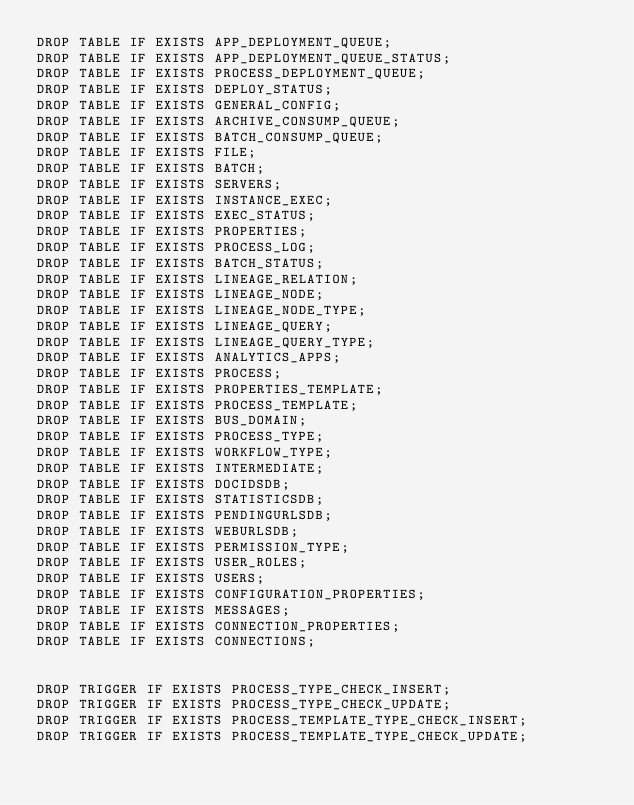Convert code to text. <code><loc_0><loc_0><loc_500><loc_500><_SQL_>DROP TABLE IF EXISTS APP_DEPLOYMENT_QUEUE;
DROP TABLE IF EXISTS APP_DEPLOYMENT_QUEUE_STATUS;
DROP TABLE IF EXISTS PROCESS_DEPLOYMENT_QUEUE;
DROP TABLE IF EXISTS DEPLOY_STATUS;
DROP TABLE IF EXISTS GENERAL_CONFIG;
DROP TABLE IF EXISTS ARCHIVE_CONSUMP_QUEUE;
DROP TABLE IF EXISTS BATCH_CONSUMP_QUEUE;
DROP TABLE IF EXISTS FILE;
DROP TABLE IF EXISTS BATCH;
DROP TABLE IF EXISTS SERVERS;
DROP TABLE IF EXISTS INSTANCE_EXEC;
DROP TABLE IF EXISTS EXEC_STATUS;
DROP TABLE IF EXISTS PROPERTIES;
DROP TABLE IF EXISTS PROCESS_LOG;
DROP TABLE IF EXISTS BATCH_STATUS;
DROP TABLE IF EXISTS LINEAGE_RELATION;
DROP TABLE IF EXISTS LINEAGE_NODE;
DROP TABLE IF EXISTS LINEAGE_NODE_TYPE;
DROP TABLE IF EXISTS LINEAGE_QUERY;
DROP TABLE IF EXISTS LINEAGE_QUERY_TYPE;
DROP TABLE IF EXISTS ANALYTICS_APPS;
DROP TABLE IF EXISTS PROCESS;
DROP TABLE IF EXISTS PROPERTIES_TEMPLATE;
DROP TABLE IF EXISTS PROCESS_TEMPLATE;
DROP TABLE IF EXISTS BUS_DOMAIN;
DROP TABLE IF EXISTS PROCESS_TYPE;
DROP TABLE IF EXISTS WORKFLOW_TYPE;
DROP TABLE IF EXISTS INTERMEDIATE;
DROP TABLE IF EXISTS DOCIDSDB;
DROP TABLE IF EXISTS STATISTICSDB;
DROP TABLE IF EXISTS PENDINGURLSDB;
DROP TABLE IF EXISTS WEBURLSDB;
DROP TABLE IF EXISTS PERMISSION_TYPE;
DROP TABLE IF EXISTS USER_ROLES;
DROP TABLE IF EXISTS USERS;
DROP TABLE IF EXISTS CONFIGURATION_PROPERTIES;
DROP TABLE IF EXISTS MESSAGES;
DROP TABLE IF EXISTS CONNECTION_PROPERTIES;
DROP TABLE IF EXISTS CONNECTIONS;


DROP TRIGGER IF EXISTS PROCESS_TYPE_CHECK_INSERT;
DROP TRIGGER IF EXISTS PROCESS_TYPE_CHECK_UPDATE;
DROP TRIGGER IF EXISTS PROCESS_TEMPLATE_TYPE_CHECK_INSERT;
DROP TRIGGER IF EXISTS PROCESS_TEMPLATE_TYPE_CHECK_UPDATE;
</code> 